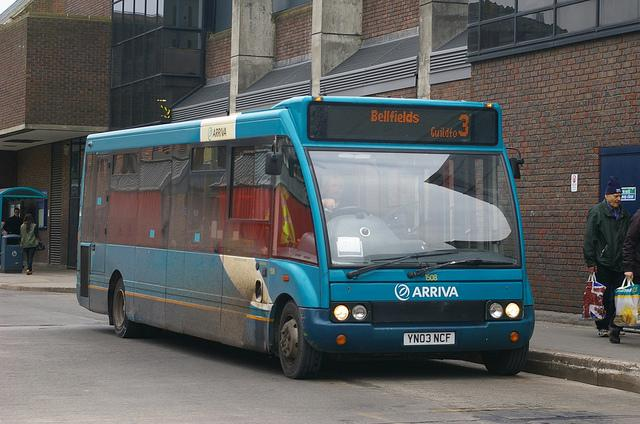How was the man able to get the plastic bags he is carrying?

Choices:
A) by shopping
B) by stealing
C) by dodging
D) by weaving by shopping 